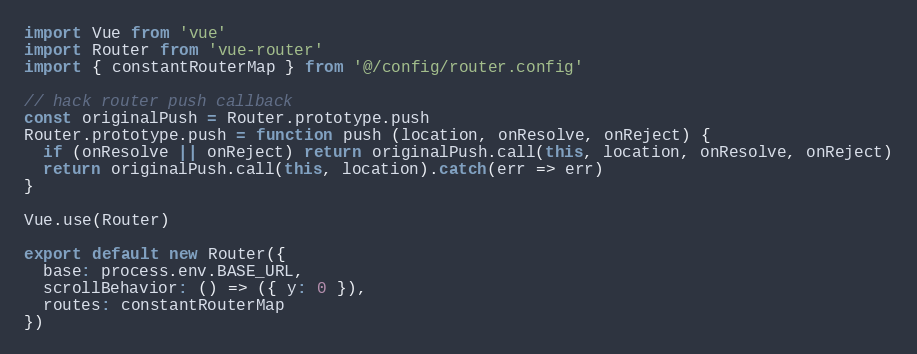Convert code to text. <code><loc_0><loc_0><loc_500><loc_500><_JavaScript_>import Vue from 'vue'
import Router from 'vue-router'
import { constantRouterMap } from '@/config/router.config'

// hack router push callback
const originalPush = Router.prototype.push
Router.prototype.push = function push (location, onResolve, onReject) {
  if (onResolve || onReject) return originalPush.call(this, location, onResolve, onReject)
  return originalPush.call(this, location).catch(err => err)
}

Vue.use(Router)

export default new Router({
  base: process.env.BASE_URL,
  scrollBehavior: () => ({ y: 0 }),
  routes: constantRouterMap
})
</code> 